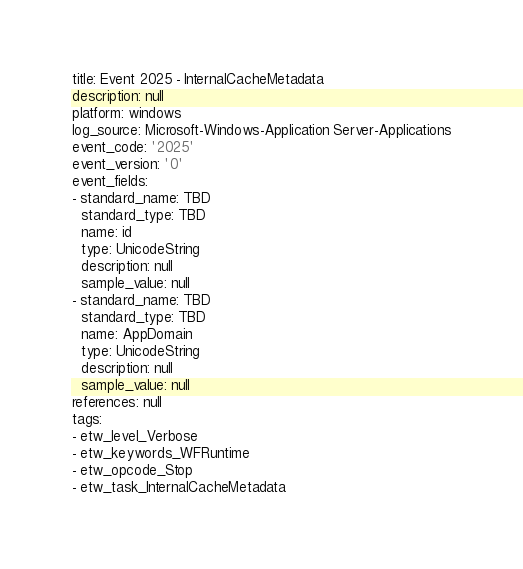Convert code to text. <code><loc_0><loc_0><loc_500><loc_500><_YAML_>title: Event 2025 - InternalCacheMetadata
description: null
platform: windows
log_source: Microsoft-Windows-Application Server-Applications
event_code: '2025'
event_version: '0'
event_fields:
- standard_name: TBD
  standard_type: TBD
  name: id
  type: UnicodeString
  description: null
  sample_value: null
- standard_name: TBD
  standard_type: TBD
  name: AppDomain
  type: UnicodeString
  description: null
  sample_value: null
references: null
tags:
- etw_level_Verbose
- etw_keywords_WFRuntime
- etw_opcode_Stop
- etw_task_InternalCacheMetadata
</code> 